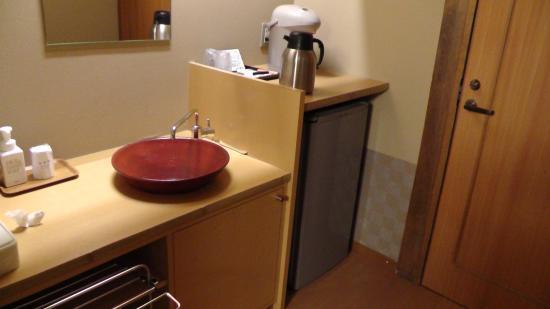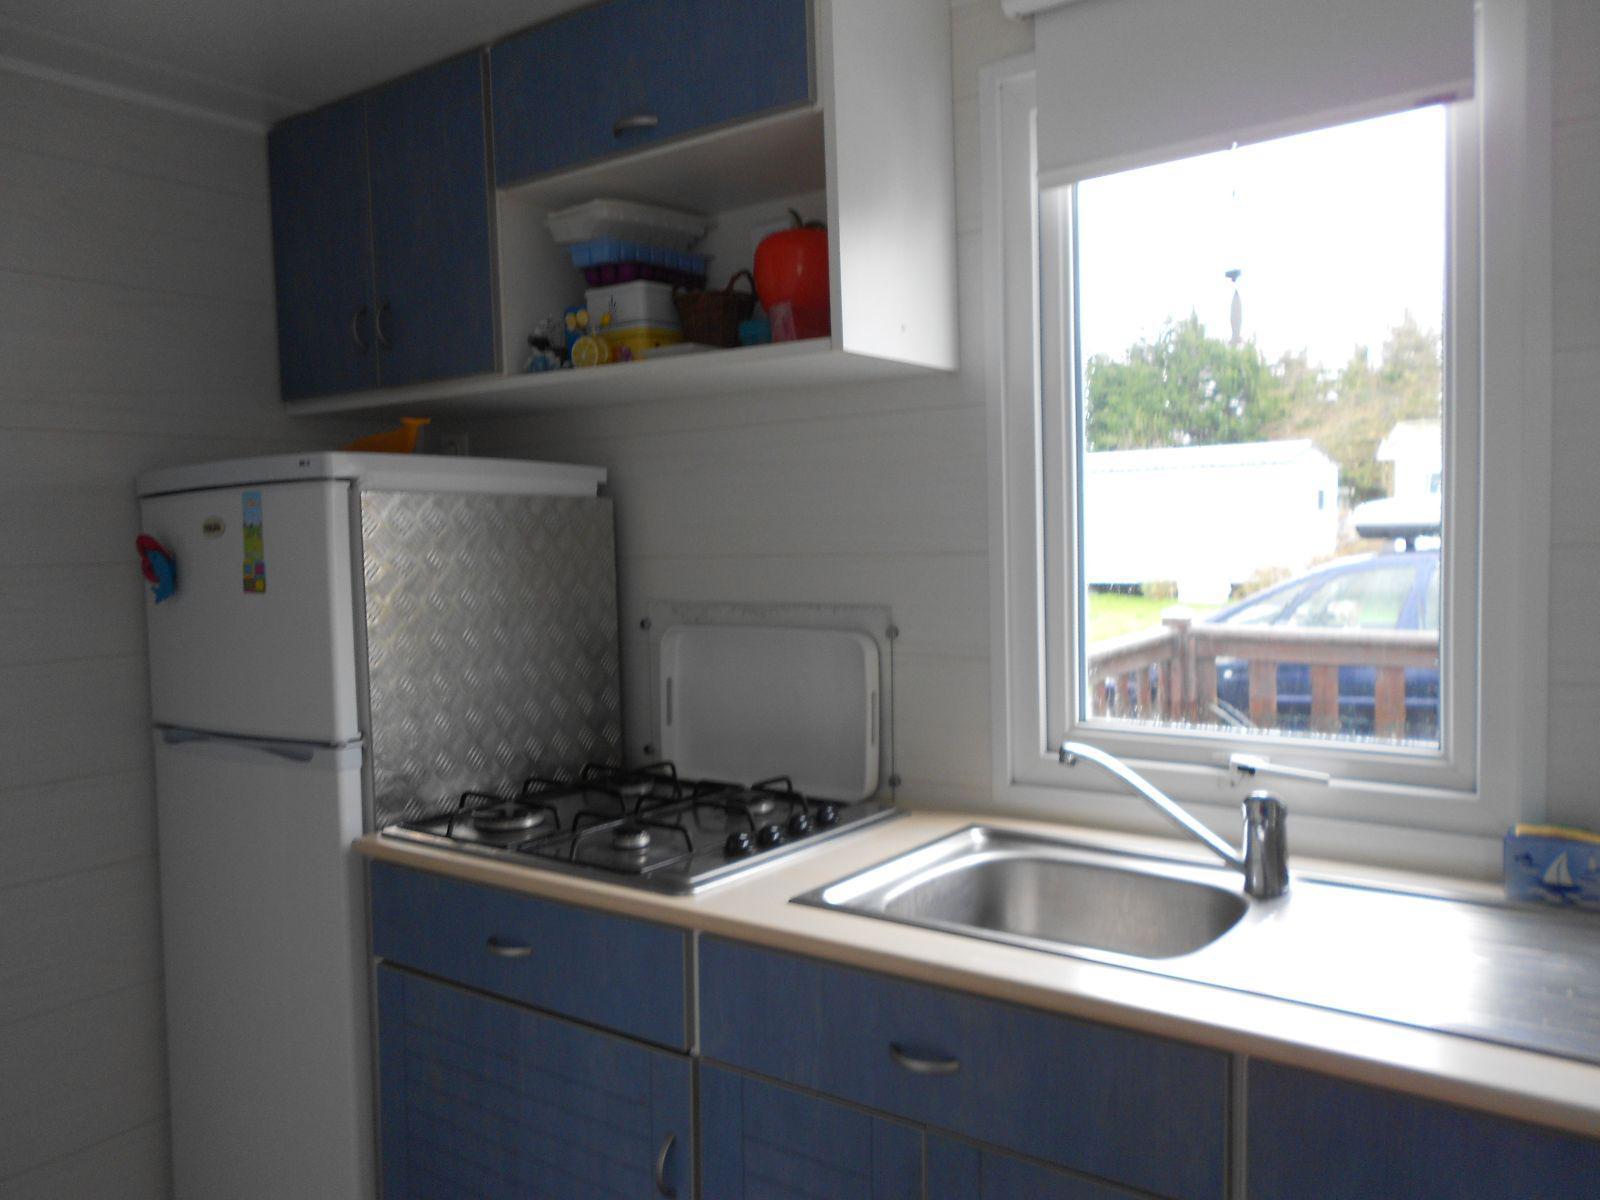The first image is the image on the left, the second image is the image on the right. Given the left and right images, does the statement "There is a refrigerator next to a counter containing a wash basin." hold true? Answer yes or no. Yes. The first image is the image on the left, the second image is the image on the right. Analyze the images presented: Is the assertion "A mirror sits over the sink in the image on the right." valid? Answer yes or no. No. 